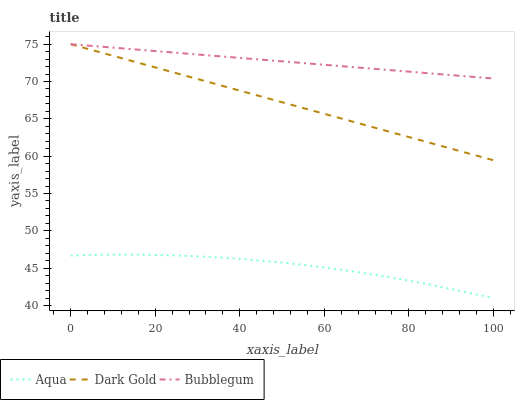Does Aqua have the minimum area under the curve?
Answer yes or no. Yes. Does Bubblegum have the maximum area under the curve?
Answer yes or no. Yes. Does Dark Gold have the minimum area under the curve?
Answer yes or no. No. Does Dark Gold have the maximum area under the curve?
Answer yes or no. No. Is Dark Gold the smoothest?
Answer yes or no. Yes. Is Aqua the roughest?
Answer yes or no. Yes. Is Bubblegum the smoothest?
Answer yes or no. No. Is Bubblegum the roughest?
Answer yes or no. No. Does Aqua have the lowest value?
Answer yes or no. Yes. Does Dark Gold have the lowest value?
Answer yes or no. No. Does Dark Gold have the highest value?
Answer yes or no. Yes. Is Aqua less than Bubblegum?
Answer yes or no. Yes. Is Bubblegum greater than Aqua?
Answer yes or no. Yes. Does Bubblegum intersect Dark Gold?
Answer yes or no. Yes. Is Bubblegum less than Dark Gold?
Answer yes or no. No. Is Bubblegum greater than Dark Gold?
Answer yes or no. No. Does Aqua intersect Bubblegum?
Answer yes or no. No. 